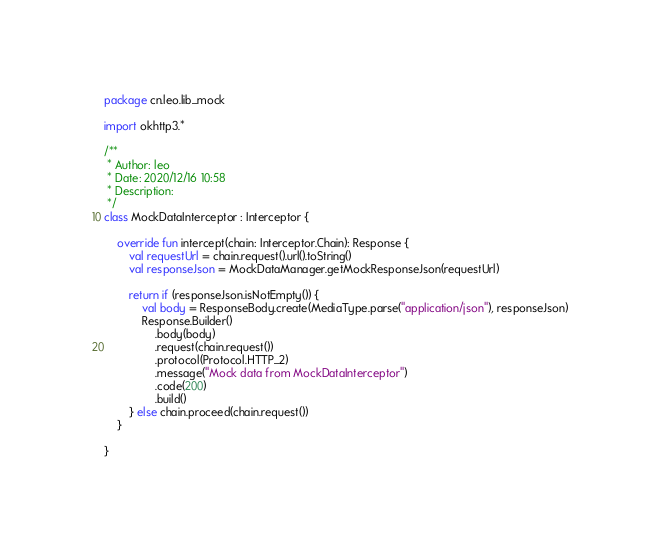<code> <loc_0><loc_0><loc_500><loc_500><_Kotlin_>package cn.leo.lib_mock

import okhttp3.*

/**
 * Author: leo
 * Date: 2020/12/16 10:58
 * Description:
 */
class MockDataInterceptor : Interceptor {

    override fun intercept(chain: Interceptor.Chain): Response {
        val requestUrl = chain.request().url().toString()
        val responseJson = MockDataManager.getMockResponseJson(requestUrl)

        return if (responseJson.isNotEmpty()) {
            val body = ResponseBody.create(MediaType.parse("application/json"), responseJson)
            Response.Builder()
                .body(body)
                .request(chain.request())
                .protocol(Protocol.HTTP_2)
                .message("Mock data from MockDataInterceptor")
                .code(200)
                .build()
        } else chain.proceed(chain.request())
    }

}</code> 